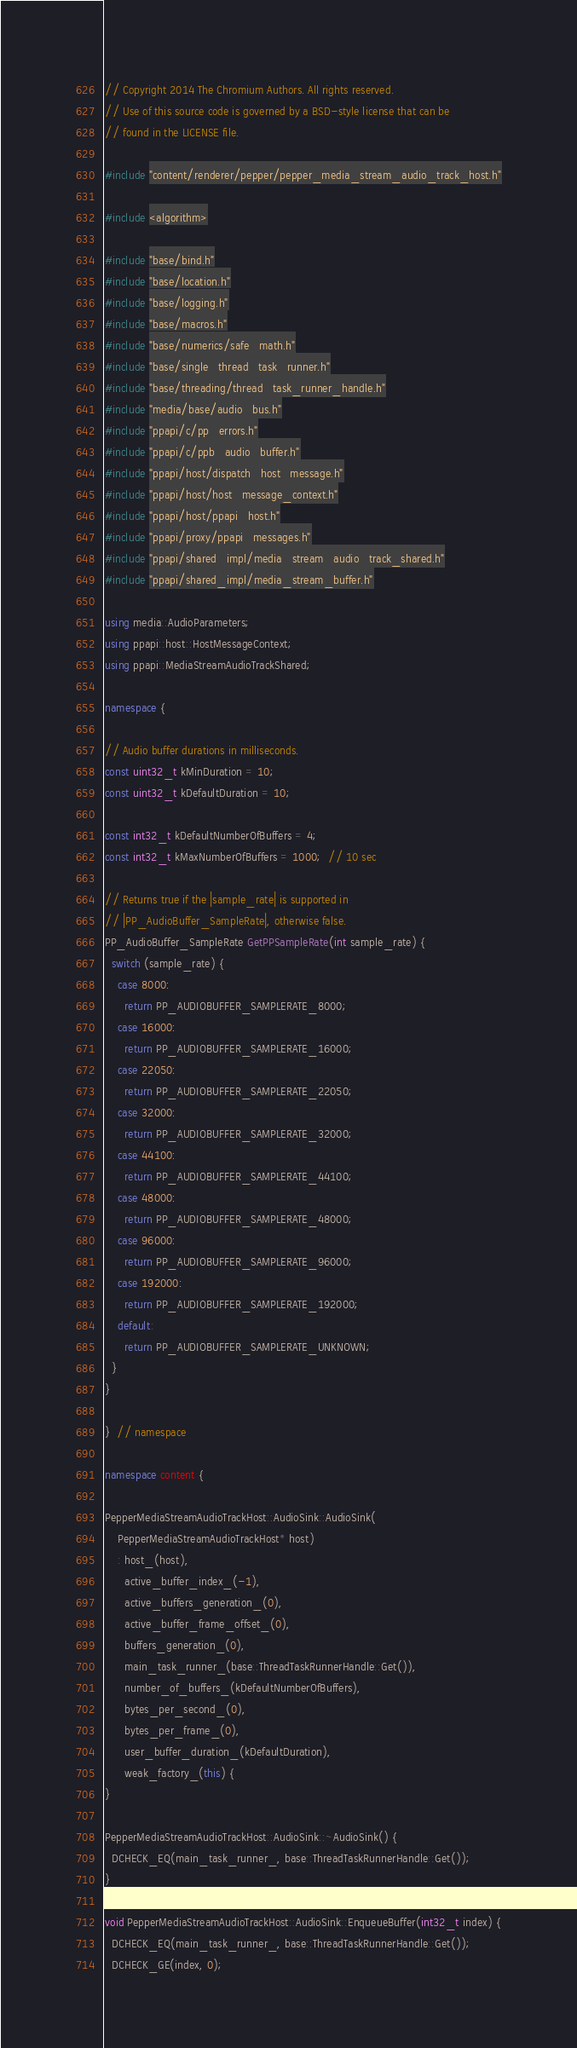Convert code to text. <code><loc_0><loc_0><loc_500><loc_500><_C++_>// Copyright 2014 The Chromium Authors. All rights reserved.
// Use of this source code is governed by a BSD-style license that can be
// found in the LICENSE file.

#include "content/renderer/pepper/pepper_media_stream_audio_track_host.h"

#include <algorithm>

#include "base/bind.h"
#include "base/location.h"
#include "base/logging.h"
#include "base/macros.h"
#include "base/numerics/safe_math.h"
#include "base/single_thread_task_runner.h"
#include "base/threading/thread_task_runner_handle.h"
#include "media/base/audio_bus.h"
#include "ppapi/c/pp_errors.h"
#include "ppapi/c/ppb_audio_buffer.h"
#include "ppapi/host/dispatch_host_message.h"
#include "ppapi/host/host_message_context.h"
#include "ppapi/host/ppapi_host.h"
#include "ppapi/proxy/ppapi_messages.h"
#include "ppapi/shared_impl/media_stream_audio_track_shared.h"
#include "ppapi/shared_impl/media_stream_buffer.h"

using media::AudioParameters;
using ppapi::host::HostMessageContext;
using ppapi::MediaStreamAudioTrackShared;

namespace {

// Audio buffer durations in milliseconds.
const uint32_t kMinDuration = 10;
const uint32_t kDefaultDuration = 10;

const int32_t kDefaultNumberOfBuffers = 4;
const int32_t kMaxNumberOfBuffers = 1000;  // 10 sec

// Returns true if the |sample_rate| is supported in
// |PP_AudioBuffer_SampleRate|, otherwise false.
PP_AudioBuffer_SampleRate GetPPSampleRate(int sample_rate) {
  switch (sample_rate) {
    case 8000:
      return PP_AUDIOBUFFER_SAMPLERATE_8000;
    case 16000:
      return PP_AUDIOBUFFER_SAMPLERATE_16000;
    case 22050:
      return PP_AUDIOBUFFER_SAMPLERATE_22050;
    case 32000:
      return PP_AUDIOBUFFER_SAMPLERATE_32000;
    case 44100:
      return PP_AUDIOBUFFER_SAMPLERATE_44100;
    case 48000:
      return PP_AUDIOBUFFER_SAMPLERATE_48000;
    case 96000:
      return PP_AUDIOBUFFER_SAMPLERATE_96000;
    case 192000:
      return PP_AUDIOBUFFER_SAMPLERATE_192000;
    default:
      return PP_AUDIOBUFFER_SAMPLERATE_UNKNOWN;
  }
}

}  // namespace

namespace content {

PepperMediaStreamAudioTrackHost::AudioSink::AudioSink(
    PepperMediaStreamAudioTrackHost* host)
    : host_(host),
      active_buffer_index_(-1),
      active_buffers_generation_(0),
      active_buffer_frame_offset_(0),
      buffers_generation_(0),
      main_task_runner_(base::ThreadTaskRunnerHandle::Get()),
      number_of_buffers_(kDefaultNumberOfBuffers),
      bytes_per_second_(0),
      bytes_per_frame_(0),
      user_buffer_duration_(kDefaultDuration),
      weak_factory_(this) {
}

PepperMediaStreamAudioTrackHost::AudioSink::~AudioSink() {
  DCHECK_EQ(main_task_runner_, base::ThreadTaskRunnerHandle::Get());
}

void PepperMediaStreamAudioTrackHost::AudioSink::EnqueueBuffer(int32_t index) {
  DCHECK_EQ(main_task_runner_, base::ThreadTaskRunnerHandle::Get());
  DCHECK_GE(index, 0);</code> 